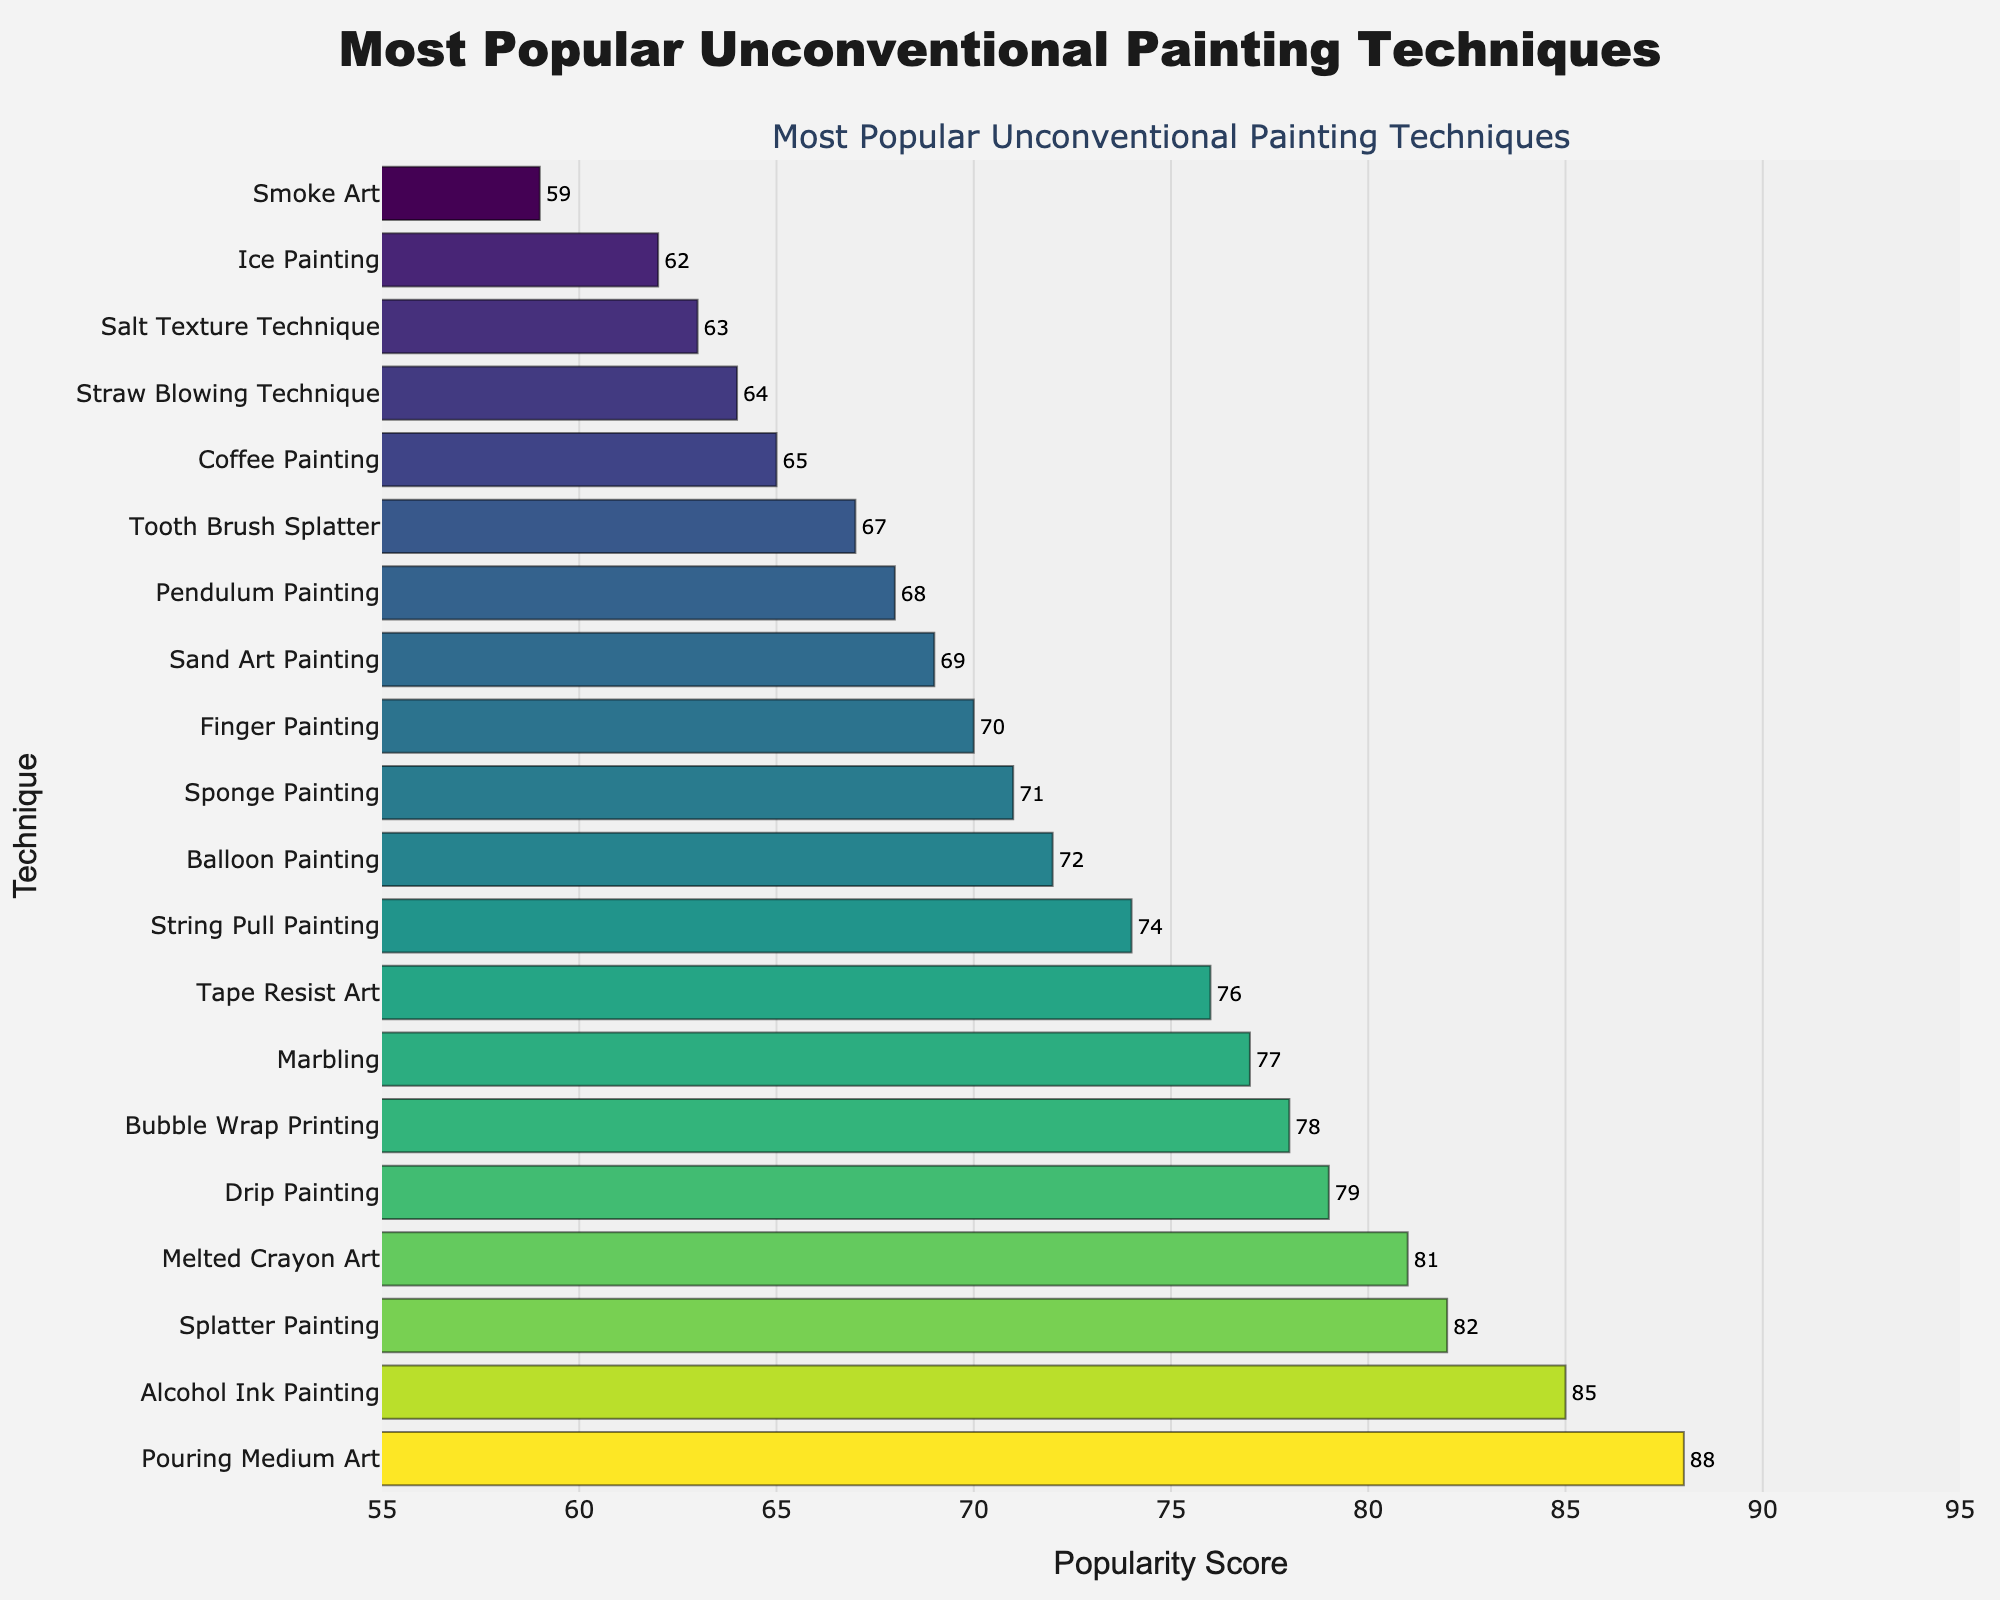Which technique has the highest popularity score? The bar that reaches the farthest right on the x-axis represents the technique with the highest popularity score. This is "Pouring Medium Art" with a score of 88.
Answer: Pouring Medium Art Which two techniques have popularity scores greater than 80? Identify bars with values above 80 on the x-axis. These techniques are "Pouring Medium Art" (88) and "Splatter Painting" (82).
Answer: Pouring Medium Art and Splatter Painting What is the difference in popularity scores between Bubble Wrap Printing and Tape Resist Art? According to the chart, Bubble Wrap Printing has a score of 78 and Tape Resist Art has a score of 76. The difference is 78 - 76 = 2.
Answer: 2 Which technique scores higher, Balloon Painting or Finger Painting? By how much? Balloon Painting has a score of 72 and Finger Painting has a score of 70. To find out by how much, calculate 72 - 70 = 2.
Answer: Balloon Painting by 2 What is the total popularity score for the bottom three techniques? The bottom three techniques based on score are "Smoke Art" (59), "Ice Painting" (62), and "Salt Texture Technique" (63). Add these scores together: 59 + 62 + 63 = 184.
Answer: 184 Which two techniques have a popularity score closest to 65? The techniques close to 65 are "Coffee Painting" (65) and "Straw Blowing Technique" (64).
Answer: Coffee Painting and Straw Blowing Technique Identify the technique with a popularity score of 85 and its visual characteristics. Look for the bar reaching 85 on the x-axis. The technique is "Alcohol Ink Painting" which is colored accordingly to the Viridis color scale and highlighted in a vibrant hue.
Answer: Alcohol Ink Painting Which techniques have a score between 70 and 75? The techniques within this score range are "Finger Painting" (70), "Sponge Painting" (71), "Balloon Painting" (72), and "String Pull Painting" (74).
Answer: Finger Painting, Sponge Painting, Balloon Painting, String Pull Painting What is the average popularity score of Tape Resist Art, Drip Painting, and Marbling? Calculate the scores of these techniques: Tape Resist Art (76), Drip Painting (79), and Marbling (77). Add them and divide by the number of techniques: (76 + 79 + 77) / 3 = 77.33.
Answer: 77.33 